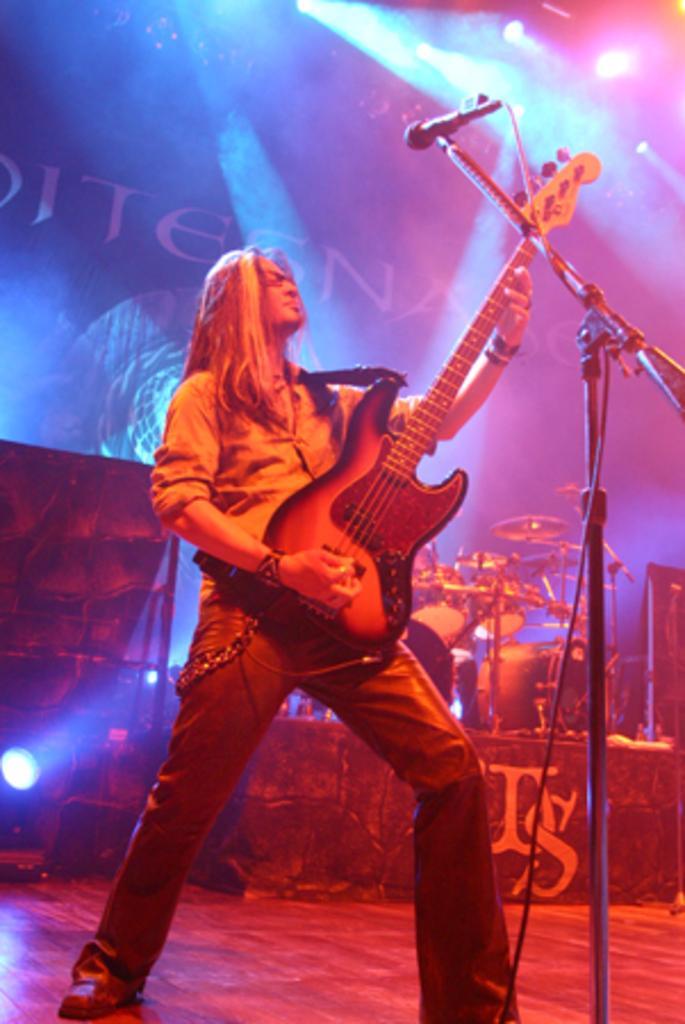How would you summarize this image in a sentence or two? In this image there is one woman who is standing and she is holding a guitar in front of her there is one mike and on the background there is wall and lights and on the left side of the image there are drums. 